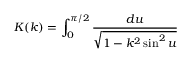Convert formula to latex. <formula><loc_0><loc_0><loc_500><loc_500>K ( k ) = \int _ { 0 } ^ { \pi / 2 } \frac { d u } { \sqrt { 1 - k ^ { 2 } \sin ^ { 2 } u } }</formula> 